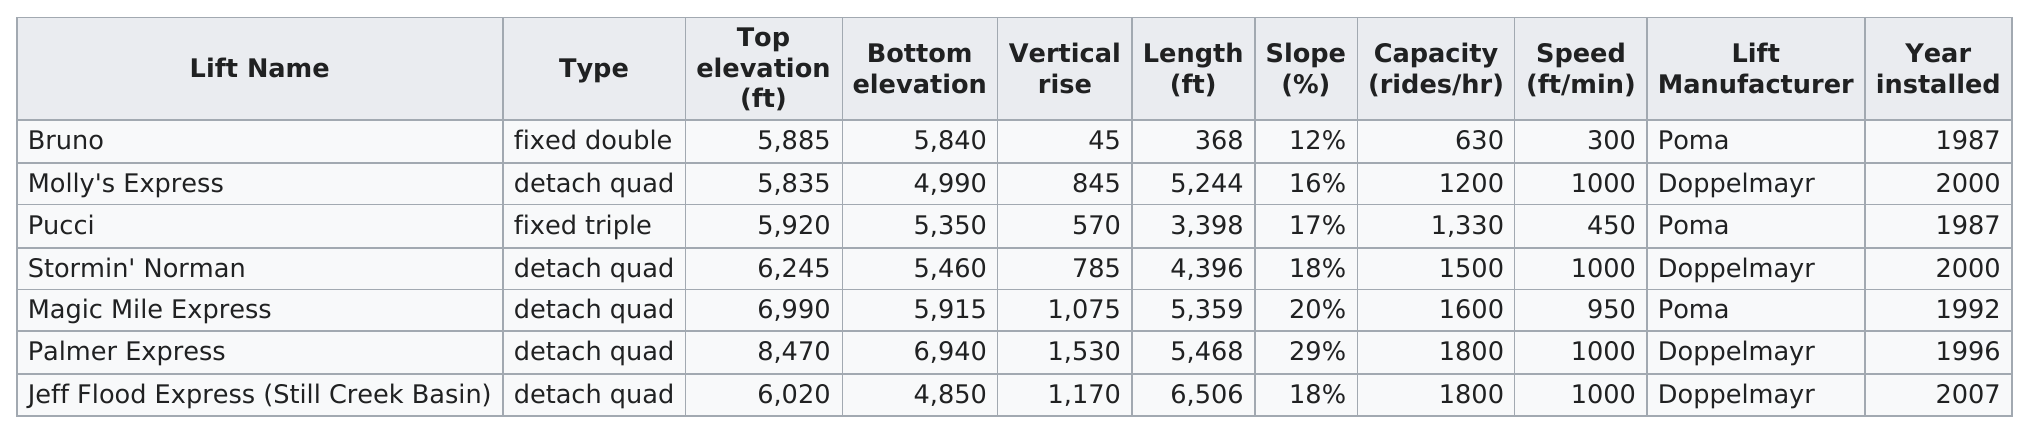Identify some key points in this picture. What lift has the least passenger capacity per hour? Bruno. There are a total of 5 detach quad-type lifts in the building. The capacity of the Timberline Lodge lift is limited to a maximum of 1800 rides per hour. The following lifts were not manufactured by Poma: Molly's Express, Stormin' Norman, Palmer Express, and Jeff Flood Express (Still Creek Basin). The Jeff Flood Express, located at Still Creek Basin, has the same capacity as the Palmer Express. 